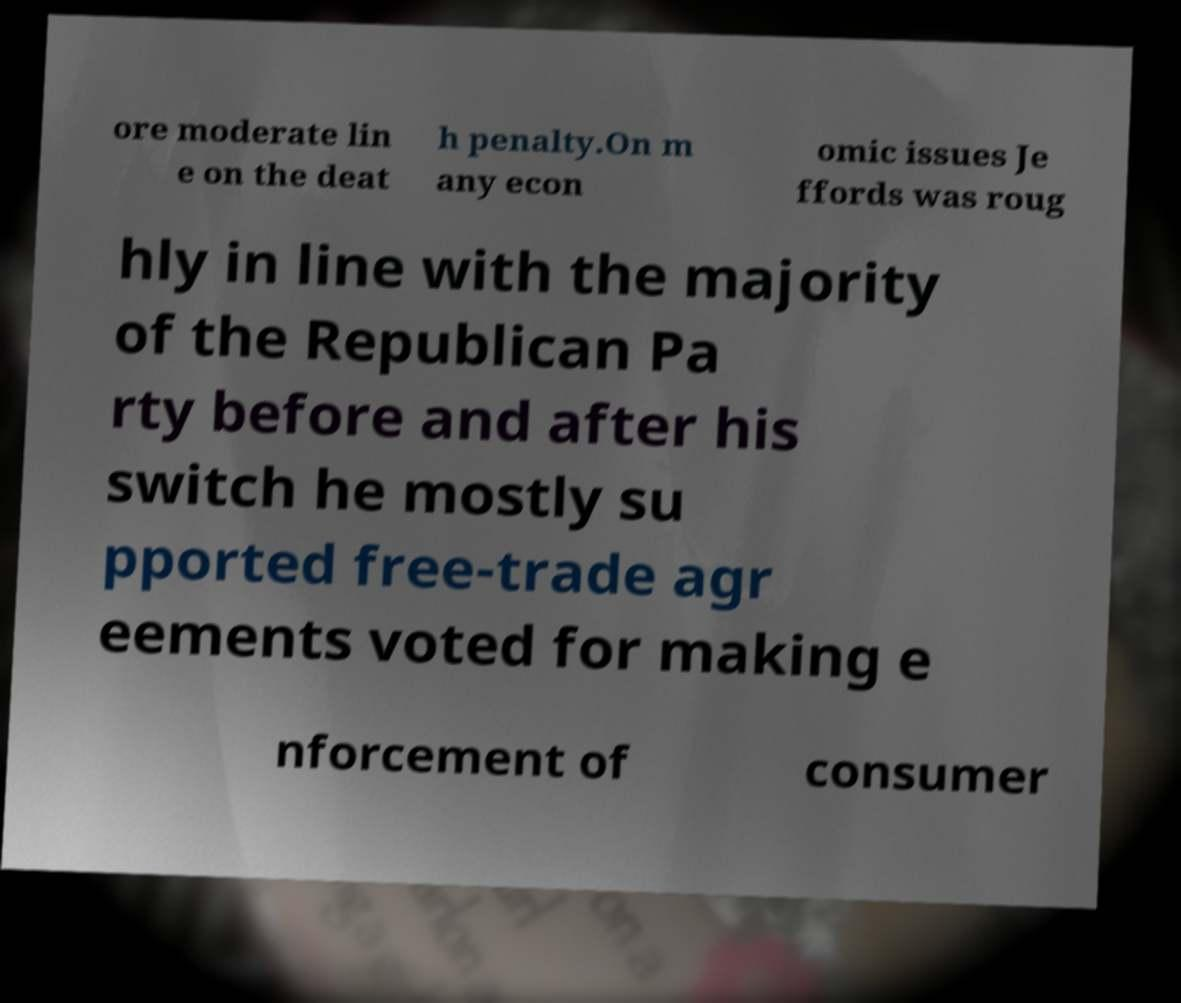Can you read and provide the text displayed in the image?This photo seems to have some interesting text. Can you extract and type it out for me? ore moderate lin e on the deat h penalty.On m any econ omic issues Je ffords was roug hly in line with the majority of the Republican Pa rty before and after his switch he mostly su pported free-trade agr eements voted for making e nforcement of consumer 